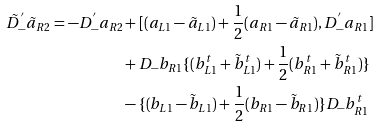Convert formula to latex. <formula><loc_0><loc_0><loc_500><loc_500>\tilde { D } _ { - } ^ { ^ { \prime } } \tilde { a } _ { R 2 } = - D _ { - } ^ { ^ { \prime } } a _ { R 2 } & + [ ( a _ { L 1 } - \tilde { a } _ { L 1 } ) + \frac { 1 } { 2 } ( a _ { R 1 } - \tilde { a } _ { R 1 } ) , D _ { - } ^ { ^ { \prime } } a _ { R 1 } ] \\ & + D _ { - } b _ { R 1 } \{ ( b _ { L 1 } ^ { t } + \tilde { b } _ { L 1 } ^ { t } ) + \frac { 1 } { 2 } ( b _ { R 1 } ^ { t } + \tilde { b } _ { R 1 } ^ { t } ) \} \\ & - \{ ( b _ { L 1 } - \tilde { b } _ { L 1 } ) + \frac { 1 } { 2 } ( b _ { R 1 } - \tilde { b } _ { R 1 } ) \} D _ { - } b _ { R 1 } ^ { t }</formula> 